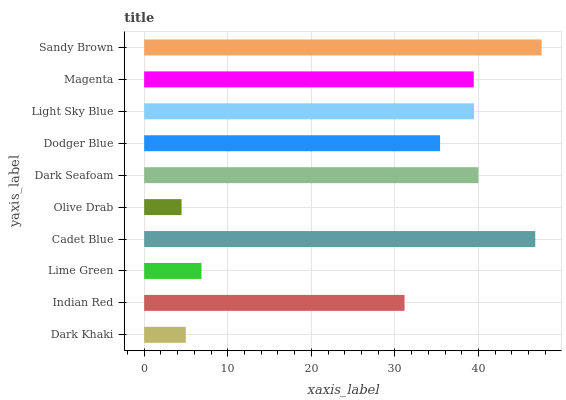Is Olive Drab the minimum?
Answer yes or no. Yes. Is Sandy Brown the maximum?
Answer yes or no. Yes. Is Indian Red the minimum?
Answer yes or no. No. Is Indian Red the maximum?
Answer yes or no. No. Is Indian Red greater than Dark Khaki?
Answer yes or no. Yes. Is Dark Khaki less than Indian Red?
Answer yes or no. Yes. Is Dark Khaki greater than Indian Red?
Answer yes or no. No. Is Indian Red less than Dark Khaki?
Answer yes or no. No. Is Magenta the high median?
Answer yes or no. Yes. Is Dodger Blue the low median?
Answer yes or no. Yes. Is Cadet Blue the high median?
Answer yes or no. No. Is Dark Khaki the low median?
Answer yes or no. No. 